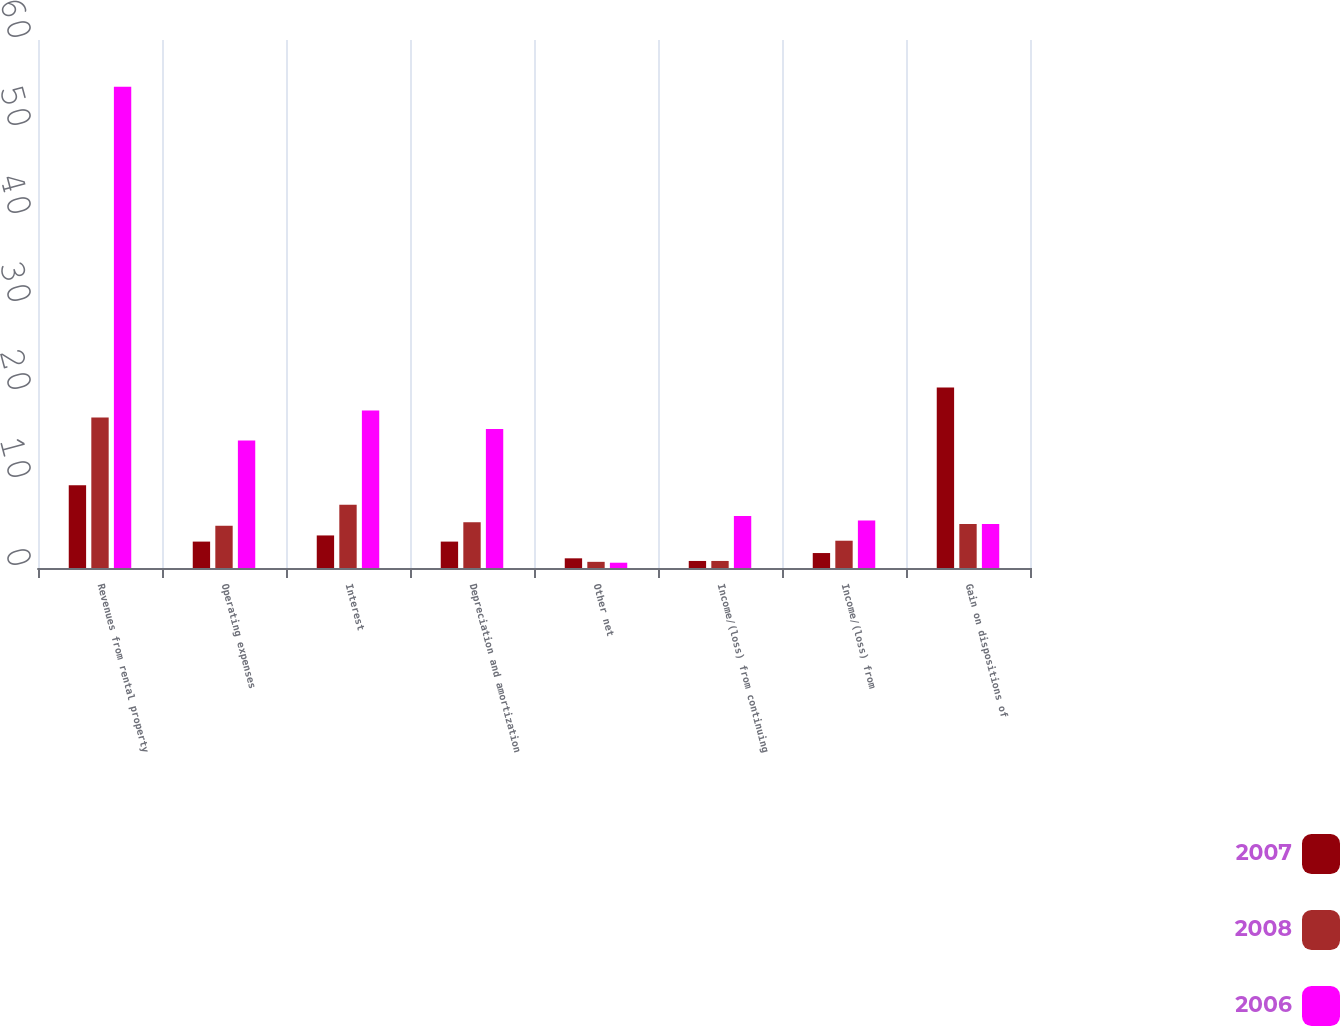Convert chart to OTSL. <chart><loc_0><loc_0><loc_500><loc_500><stacked_bar_chart><ecel><fcel>Revenues from rental property<fcel>Operating expenses<fcel>Interest<fcel>Depreciation and amortization<fcel>Other net<fcel>Income/(loss) from continuing<fcel>Income/(loss) from<fcel>Gain on dispositions of<nl><fcel>2007<fcel>9.4<fcel>3<fcel>3.7<fcel>3<fcel>1.1<fcel>0.8<fcel>1.7<fcel>20.5<nl><fcel>2008<fcel>17.1<fcel>4.8<fcel>7.2<fcel>5.2<fcel>0.7<fcel>0.8<fcel>3.1<fcel>5<nl><fcel>2006<fcel>54.7<fcel>14.5<fcel>17.9<fcel>15.8<fcel>0.6<fcel>5.9<fcel>5.4<fcel>5<nl></chart> 